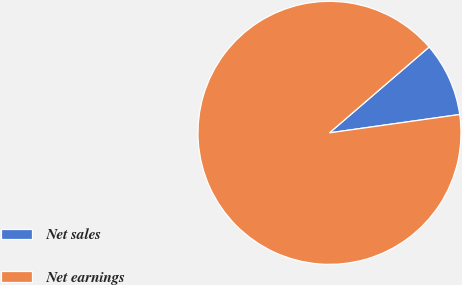<chart> <loc_0><loc_0><loc_500><loc_500><pie_chart><fcel>Net sales<fcel>Net earnings<nl><fcel>9.09%<fcel>90.91%<nl></chart> 